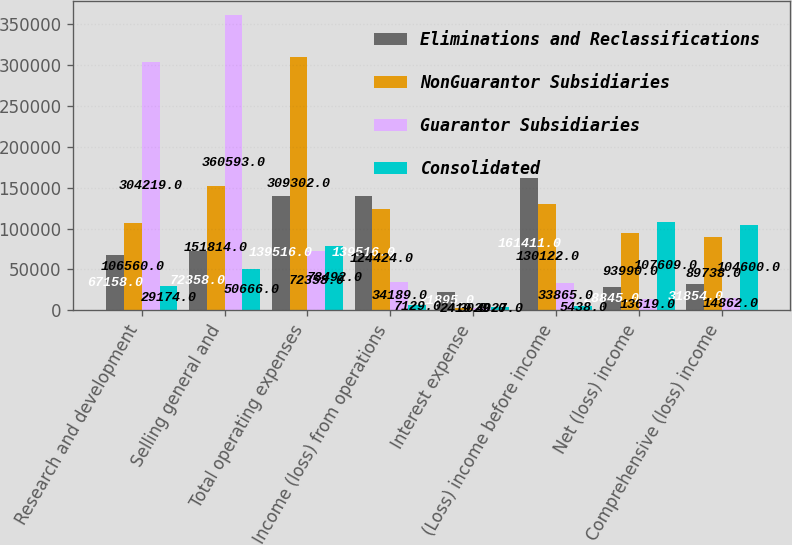Convert chart. <chart><loc_0><loc_0><loc_500><loc_500><stacked_bar_chart><ecel><fcel>Research and development<fcel>Selling general and<fcel>Total operating expenses<fcel>Income (loss) from operations<fcel>Interest expense<fcel>(Loss) income before income<fcel>Net (loss) income<fcel>Comprehensive (loss) income<nl><fcel>Eliminations and Reclassifications<fcel>67158<fcel>72358<fcel>139516<fcel>139516<fcel>21895<fcel>161411<fcel>28845<fcel>31854<nl><fcel>NonGuarantor Subsidiaries<fcel>106560<fcel>151814<fcel>309302<fcel>124424<fcel>2419<fcel>130122<fcel>93990<fcel>89738<nl><fcel>Guarantor Subsidiaries<fcel>304219<fcel>360593<fcel>72358<fcel>34189<fcel>3029<fcel>33865<fcel>13619<fcel>14862<nl><fcel>Consolidated<fcel>29174<fcel>50666<fcel>78492<fcel>7129<fcel>4027<fcel>5438<fcel>107609<fcel>104600<nl></chart> 